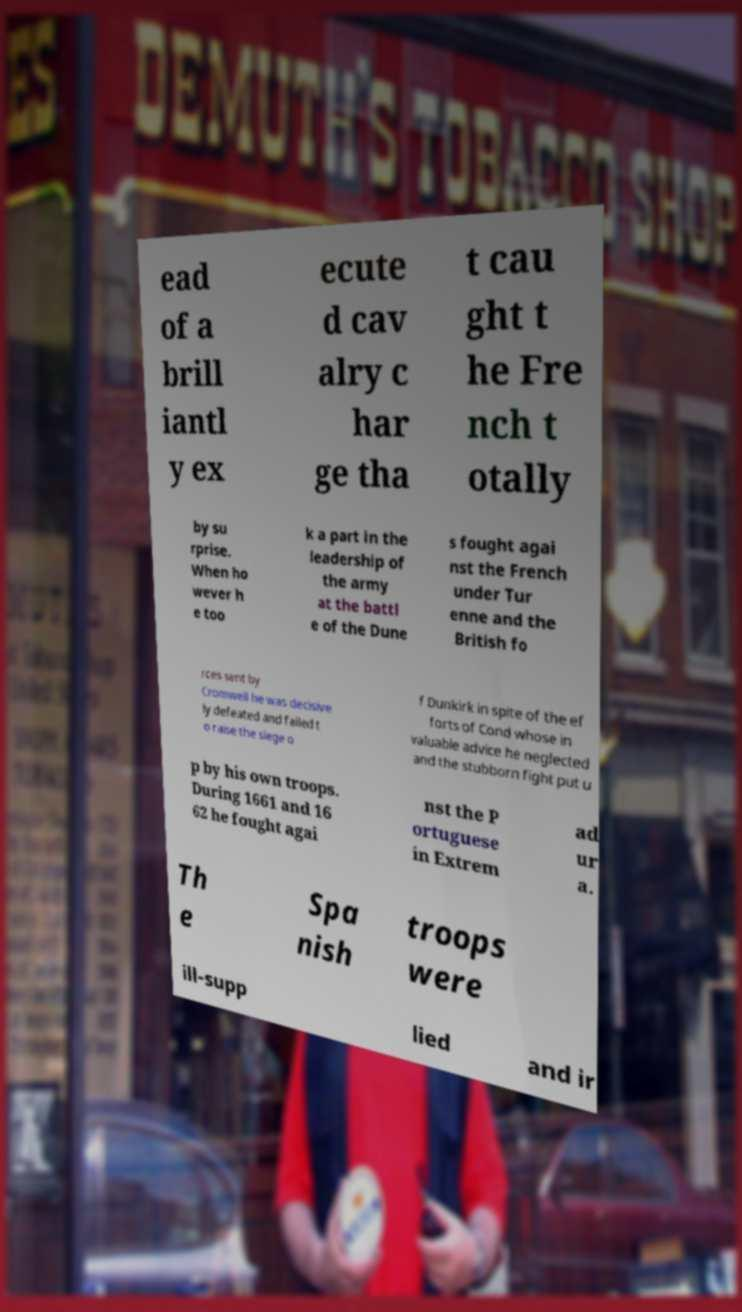There's text embedded in this image that I need extracted. Can you transcribe it verbatim? ead of a brill iantl y ex ecute d cav alry c har ge tha t cau ght t he Fre nch t otally by su rprise. When ho wever h e too k a part in the leadership of the army at the battl e of the Dune s fought agai nst the French under Tur enne and the British fo rces sent by Cromwell he was decisive ly defeated and failed t o raise the siege o f Dunkirk in spite of the ef forts of Cond whose in valuable advice he neglected and the stubborn fight put u p by his own troops. During 1661 and 16 62 he fought agai nst the P ortuguese in Extrem ad ur a. Th e Spa nish troops were ill-supp lied and ir 